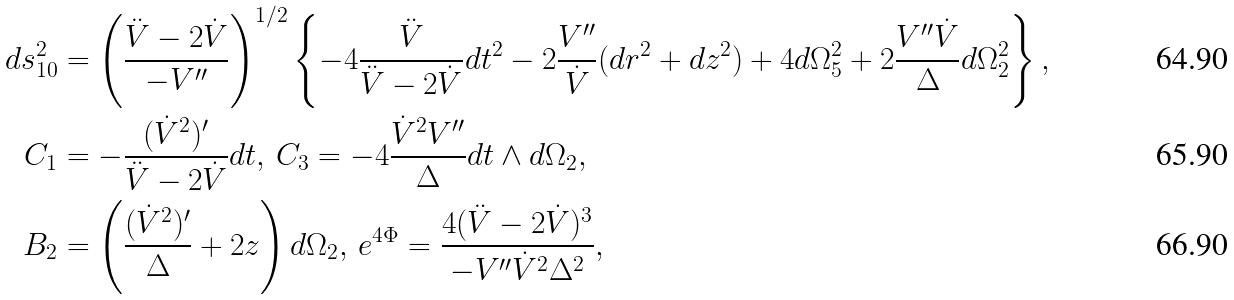Convert formula to latex. <formula><loc_0><loc_0><loc_500><loc_500>d s _ { 1 0 } ^ { 2 } & = \left ( \frac { \ddot { V } - 2 \dot { V } } { - V ^ { \prime \prime } } \right ) ^ { 1 / 2 } \left \{ - 4 \frac { \ddot { V } } { \ddot { V } - 2 \dot { V } } d t ^ { 2 } - 2 \frac { V ^ { \prime \prime } } { \dot { V } } ( d r ^ { 2 } + d z ^ { 2 } ) + 4 d \Omega _ { 5 } ^ { 2 } + 2 \frac { V ^ { \prime \prime } \dot { V } } { \Delta } d \Omega _ { 2 } ^ { 2 } \right \} , \\ C _ { 1 } & = - \frac { ( \dot { V } ^ { 2 } ) ^ { \prime } } { \ddot { V } - 2 \dot { V } } d t , \, C _ { 3 } = - 4 \frac { \dot { V } ^ { 2 } V ^ { \prime \prime } } { \Delta } d t \wedge d \Omega _ { 2 } , \\ B _ { 2 } & = \left ( \frac { ( \dot { V } ^ { 2 } ) ^ { \prime } } { \Delta } + 2 z \right ) d \Omega _ { 2 } , \, e ^ { 4 \Phi } = \frac { 4 ( \ddot { V } - 2 \dot { V } ) ^ { 3 } } { - V ^ { \prime \prime } \dot { V } ^ { 2 } \Delta ^ { 2 } } ,</formula> 